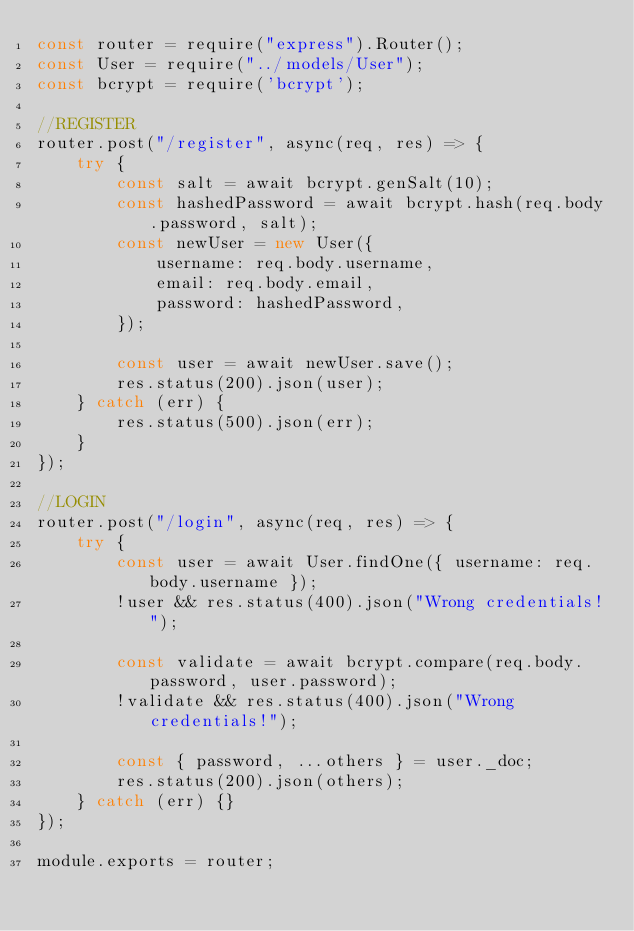<code> <loc_0><loc_0><loc_500><loc_500><_JavaScript_>const router = require("express").Router();
const User = require("../models/User");
const bcrypt = require('bcrypt');

//REGISTER
router.post("/register", async(req, res) => {
    try {
        const salt = await bcrypt.genSalt(10);
        const hashedPassword = await bcrypt.hash(req.body.password, salt);
        const newUser = new User({
            username: req.body.username,
            email: req.body.email,
            password: hashedPassword,
        });

        const user = await newUser.save();
        res.status(200).json(user);
    } catch (err) {
        res.status(500).json(err);
    }
});

//LOGIN
router.post("/login", async(req, res) => {
    try {
        const user = await User.findOne({ username: req.body.username });
        !user && res.status(400).json("Wrong credentials!");

        const validate = await bcrypt.compare(req.body.password, user.password);
        !validate && res.status(400).json("Wrong credentials!");

        const { password, ...others } = user._doc;
        res.status(200).json(others);
    } catch (err) {}
});

module.exports = router;</code> 